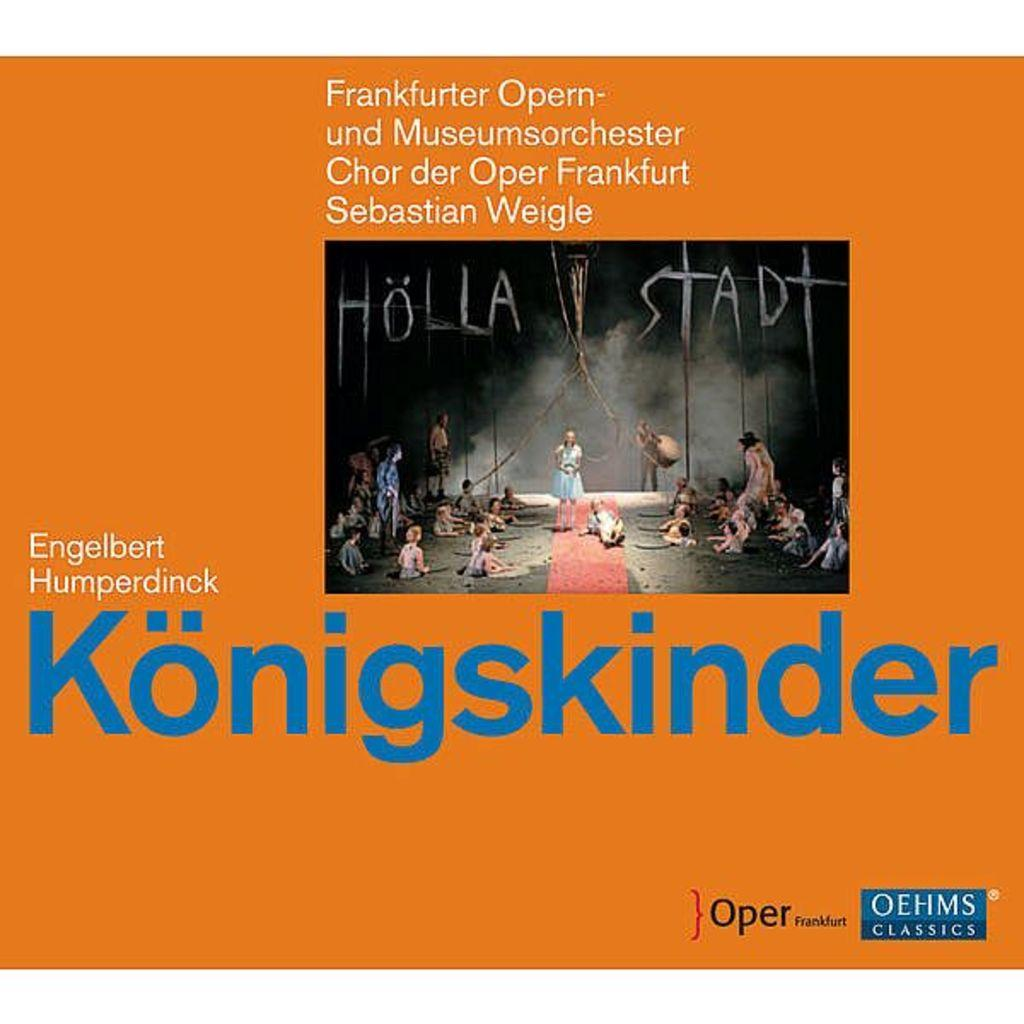<image>
Relay a brief, clear account of the picture shown. An orange cover is displayed with Konigskinder in large blue print. 